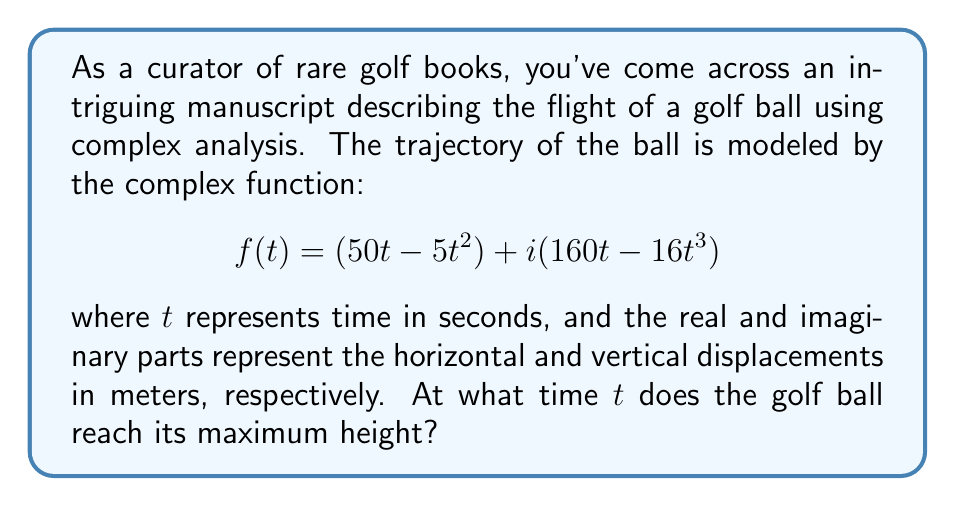Teach me how to tackle this problem. To find the time when the golf ball reaches its maximum height, we need to analyze the imaginary part of the complex function, which represents the vertical displacement.

1) The vertical displacement is given by:
   $$y(t) = 160t - 16t^3$$

2) To find the maximum height, we need to find where the derivative of $y(t)$ equals zero:
   $$\frac{dy}{dt} = 160 - 48t^2$$

3) Set this equal to zero and solve:
   $$160 - 48t^2 = 0$$
   $$48t^2 = 160$$
   $$t^2 = \frac{10}{3}$$
   $$t = \pm \sqrt{\frac{10}{3}}$$

4) Since time is positive in this context, we take the positive root:
   $$t = \sqrt{\frac{10}{3}} \approx 1.83 \text{ seconds}$$

5) To confirm this is a maximum (not a minimum), we can check the second derivative:
   $$\frac{d^2y}{dt^2} = -96t$$
   
   At $t = \sqrt{\frac{10}{3}}$, this is negative, confirming a maximum.

6) We can also calculate the maximum height reached:
   $$y(\sqrt{\frac{10}{3}}) = 160\sqrt{\frac{10}{3}} - 16(\sqrt{\frac{10}{3}})^3 \approx 133.33 \text{ meters}$$
Answer: The golf ball reaches its maximum height at $t = \sqrt{\frac{10}{3}} \approx 1.83$ seconds. 